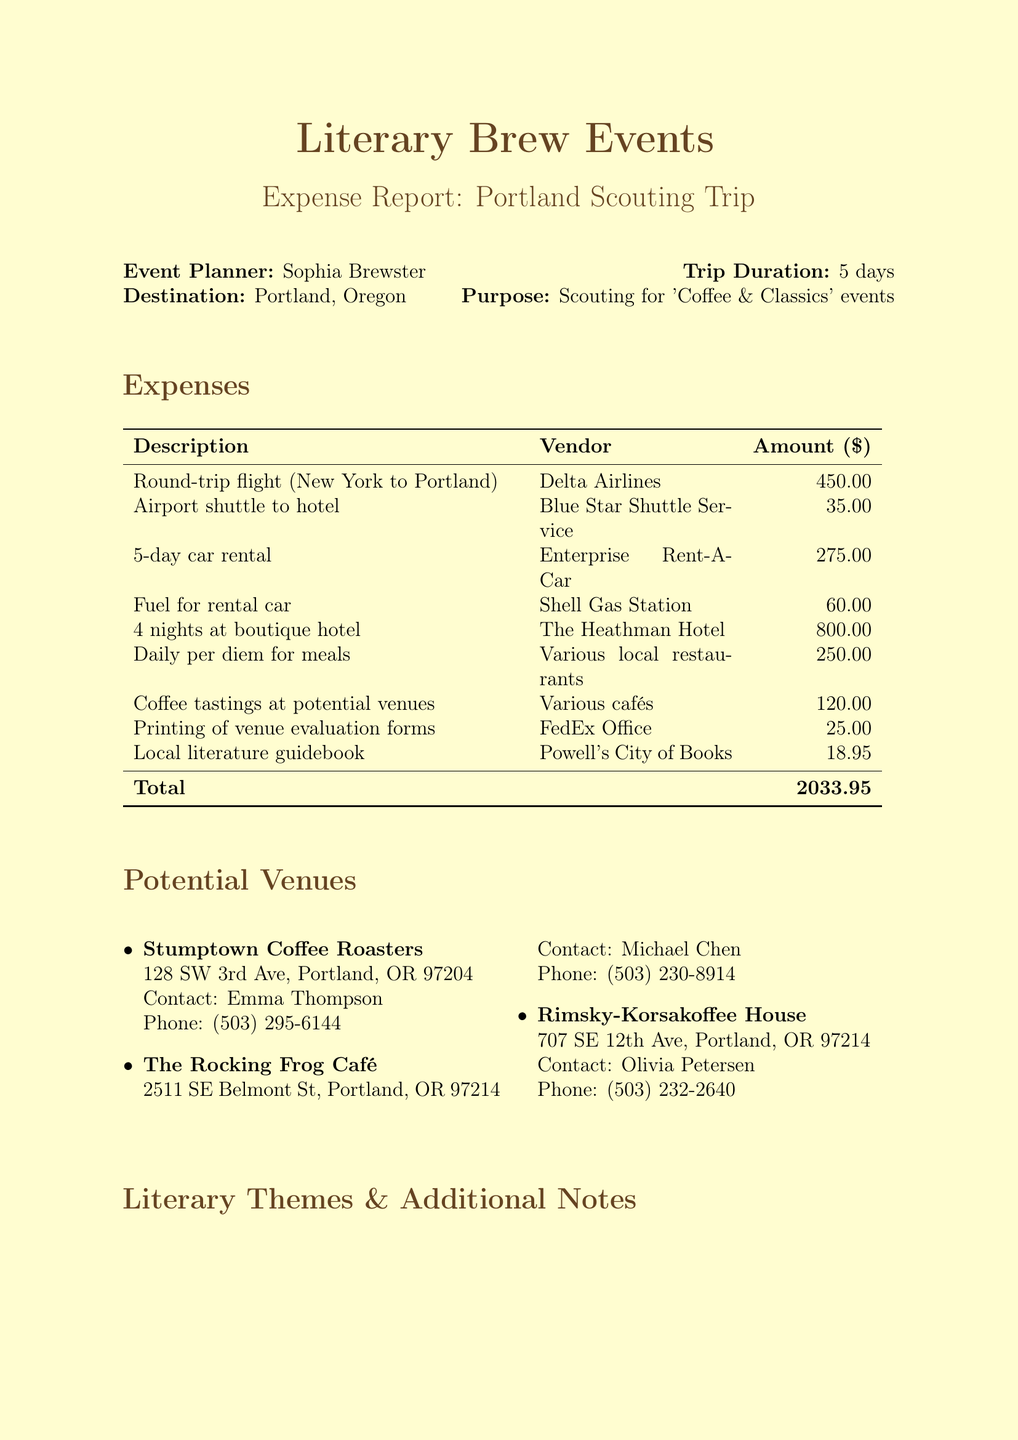What is the total amount of expenses? The total amount is found in the Expense section of the document, which adds up all individual expenses to $2033.95.
Answer: $2033.95 Who is the event planner for this trip? The document clearly states the event planner's name at the beginning, which is Sophia Brewster.
Answer: Sophia Brewster What is the purpose of the trip? The purpose is listed in the document, which indicates it is for scouting unique café locations for upcoming events.
Answer: Scouting unique café locations for upcoming 'Coffee & Classics' pop-up literary events How many nights did the event planner stay at the hotel? The number of nights at the hotel is specified in the Accommodation section, which states "4 nights at boutique hotel".
Answer: 4 nights How much was spent on coffee tastings? The amount spent on coffee tastings is provided in the Business Expenses section, which shows a total of $120.00.
Answer: $120.00 What is the name of the first potential venue? The first venue listed under Potential Venues is clearly presented, which is Stumptown Coffee Roasters.
Answer: Stumptown Coffee Roasters Which vendor provided the round-trip flight? The vendor for the round-trip flight is mentioned in the Transportation section, which is Delta Airlines.
Answer: Delta Airlines What literary themes are included in the document? The literary themes are documented under the Literary Themes section, which lists multiple themes such as "Pacific Northwest Authors".
Answer: Pacific Northwest Authors, Eco-Fiction, Contemporary Poetry, Magical Realism in Coffee Culture What city was the trip to? The destination city is stated in the document, which is Portland, Oregon.
Answer: Portland, Oregon 